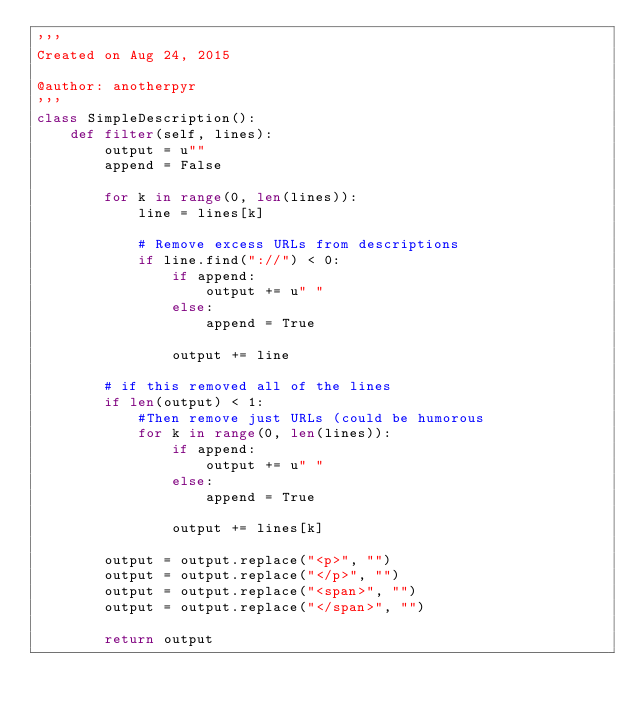<code> <loc_0><loc_0><loc_500><loc_500><_Python_>'''
Created on Aug 24, 2015

@author: anotherpyr
'''
class SimpleDescription():
    def filter(self, lines):
        output = u""
        append = False
        
        for k in range(0, len(lines)):
            line = lines[k]
           
            # Remove excess URLs from descriptions 
            if line.find("://") < 0:
                if append:
                    output += u" "
                else:
                    append = True
                    
                output += line
            
        # if this removed all of the lines
        if len(output) < 1:
            #Then remove just URLs (could be humorous
            for k in range(0, len(lines)):
                if append:
                    output += u" "
                else:
                    append = True
                    
                output += lines[k]

        output = output.replace("<p>", "")
        output = output.replace("</p>", "")
        output = output.replace("<span>", "")
        output = output.replace("</span>", "")
        
        return output</code> 